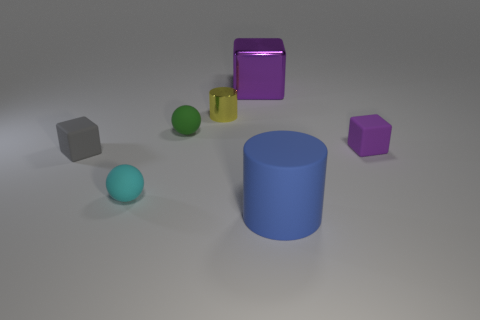Add 2 yellow rubber cubes. How many objects exist? 9 Subtract all spheres. How many objects are left? 5 Add 3 small purple blocks. How many small purple blocks are left? 4 Add 5 large brown rubber balls. How many large brown rubber balls exist? 5 Subtract 0 green blocks. How many objects are left? 7 Subtract all big metal things. Subtract all matte objects. How many objects are left? 1 